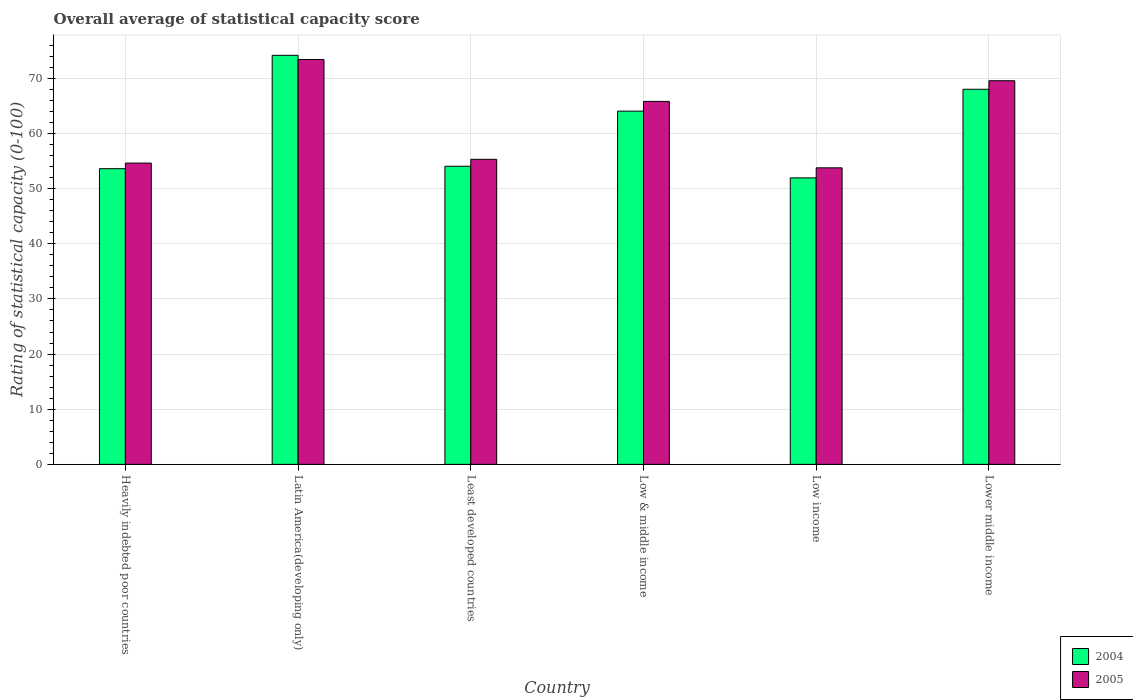What is the label of the 5th group of bars from the left?
Provide a succinct answer. Low income. What is the rating of statistical capacity in 2004 in Low income?
Your answer should be compact. 51.94. Across all countries, what is the maximum rating of statistical capacity in 2005?
Your response must be concise. 73.4. Across all countries, what is the minimum rating of statistical capacity in 2004?
Your answer should be very brief. 51.94. In which country was the rating of statistical capacity in 2004 maximum?
Offer a very short reply. Latin America(developing only). What is the total rating of statistical capacity in 2004 in the graph?
Your answer should be compact. 365.84. What is the difference between the rating of statistical capacity in 2005 in Heavily indebted poor countries and that in Least developed countries?
Ensure brevity in your answer.  -0.69. What is the difference between the rating of statistical capacity in 2005 in Least developed countries and the rating of statistical capacity in 2004 in Lower middle income?
Your answer should be compact. -12.7. What is the average rating of statistical capacity in 2004 per country?
Make the answer very short. 60.97. What is the difference between the rating of statistical capacity of/in 2005 and rating of statistical capacity of/in 2004 in Latin America(developing only)?
Keep it short and to the point. -0.76. What is the ratio of the rating of statistical capacity in 2005 in Latin America(developing only) to that in Low income?
Make the answer very short. 1.37. What is the difference between the highest and the second highest rating of statistical capacity in 2005?
Provide a succinct answer. -7.59. What is the difference between the highest and the lowest rating of statistical capacity in 2004?
Offer a very short reply. 22.22. What does the 2nd bar from the left in Heavily indebted poor countries represents?
Give a very brief answer. 2005. What does the 2nd bar from the right in Heavily indebted poor countries represents?
Offer a very short reply. 2004. How many bars are there?
Make the answer very short. 12. How many countries are there in the graph?
Provide a short and direct response. 6. Does the graph contain grids?
Your response must be concise. Yes. What is the title of the graph?
Make the answer very short. Overall average of statistical capacity score. What is the label or title of the X-axis?
Your response must be concise. Country. What is the label or title of the Y-axis?
Give a very brief answer. Rating of statistical capacity (0-100). What is the Rating of statistical capacity (0-100) of 2004 in Heavily indebted poor countries?
Your response must be concise. 53.61. What is the Rating of statistical capacity (0-100) of 2005 in Heavily indebted poor countries?
Your answer should be very brief. 54.63. What is the Rating of statistical capacity (0-100) in 2004 in Latin America(developing only)?
Provide a succinct answer. 74.17. What is the Rating of statistical capacity (0-100) of 2005 in Latin America(developing only)?
Ensure brevity in your answer.  73.4. What is the Rating of statistical capacity (0-100) in 2004 in Least developed countries?
Give a very brief answer. 54.05. What is the Rating of statistical capacity (0-100) of 2005 in Least developed countries?
Your answer should be compact. 55.32. What is the Rating of statistical capacity (0-100) in 2004 in Low & middle income?
Provide a short and direct response. 64.05. What is the Rating of statistical capacity (0-100) of 2005 in Low & middle income?
Provide a short and direct response. 65.81. What is the Rating of statistical capacity (0-100) in 2004 in Low income?
Ensure brevity in your answer.  51.94. What is the Rating of statistical capacity (0-100) in 2005 in Low income?
Keep it short and to the point. 53.77. What is the Rating of statistical capacity (0-100) in 2004 in Lower middle income?
Provide a short and direct response. 68.01. What is the Rating of statistical capacity (0-100) of 2005 in Lower middle income?
Ensure brevity in your answer.  69.56. Across all countries, what is the maximum Rating of statistical capacity (0-100) in 2004?
Keep it short and to the point. 74.17. Across all countries, what is the maximum Rating of statistical capacity (0-100) in 2005?
Your response must be concise. 73.4. Across all countries, what is the minimum Rating of statistical capacity (0-100) of 2004?
Offer a very short reply. 51.94. Across all countries, what is the minimum Rating of statistical capacity (0-100) of 2005?
Your answer should be very brief. 53.77. What is the total Rating of statistical capacity (0-100) in 2004 in the graph?
Your answer should be compact. 365.84. What is the total Rating of statistical capacity (0-100) of 2005 in the graph?
Give a very brief answer. 372.49. What is the difference between the Rating of statistical capacity (0-100) in 2004 in Heavily indebted poor countries and that in Latin America(developing only)?
Provide a succinct answer. -20.56. What is the difference between the Rating of statistical capacity (0-100) of 2005 in Heavily indebted poor countries and that in Latin America(developing only)?
Your answer should be compact. -18.77. What is the difference between the Rating of statistical capacity (0-100) of 2004 in Heavily indebted poor countries and that in Least developed countries?
Give a very brief answer. -0.44. What is the difference between the Rating of statistical capacity (0-100) in 2005 in Heavily indebted poor countries and that in Least developed countries?
Provide a short and direct response. -0.69. What is the difference between the Rating of statistical capacity (0-100) of 2004 in Heavily indebted poor countries and that in Low & middle income?
Offer a terse response. -10.44. What is the difference between the Rating of statistical capacity (0-100) in 2005 in Heavily indebted poor countries and that in Low & middle income?
Your response must be concise. -11.18. What is the difference between the Rating of statistical capacity (0-100) in 2004 in Heavily indebted poor countries and that in Low income?
Ensure brevity in your answer.  1.67. What is the difference between the Rating of statistical capacity (0-100) in 2005 in Heavily indebted poor countries and that in Low income?
Offer a terse response. 0.86. What is the difference between the Rating of statistical capacity (0-100) in 2004 in Heavily indebted poor countries and that in Lower middle income?
Your answer should be compact. -14.4. What is the difference between the Rating of statistical capacity (0-100) in 2005 in Heavily indebted poor countries and that in Lower middle income?
Your response must be concise. -14.93. What is the difference between the Rating of statistical capacity (0-100) of 2004 in Latin America(developing only) and that in Least developed countries?
Give a very brief answer. 20.11. What is the difference between the Rating of statistical capacity (0-100) in 2005 in Latin America(developing only) and that in Least developed countries?
Your answer should be compact. 18.09. What is the difference between the Rating of statistical capacity (0-100) in 2004 in Latin America(developing only) and that in Low & middle income?
Make the answer very short. 10.12. What is the difference between the Rating of statistical capacity (0-100) of 2005 in Latin America(developing only) and that in Low & middle income?
Ensure brevity in your answer.  7.59. What is the difference between the Rating of statistical capacity (0-100) of 2004 in Latin America(developing only) and that in Low income?
Your answer should be very brief. 22.22. What is the difference between the Rating of statistical capacity (0-100) in 2005 in Latin America(developing only) and that in Low income?
Your response must be concise. 19.63. What is the difference between the Rating of statistical capacity (0-100) of 2004 in Latin America(developing only) and that in Lower middle income?
Ensure brevity in your answer.  6.16. What is the difference between the Rating of statistical capacity (0-100) in 2005 in Latin America(developing only) and that in Lower middle income?
Offer a very short reply. 3.84. What is the difference between the Rating of statistical capacity (0-100) in 2004 in Least developed countries and that in Low & middle income?
Your answer should be very brief. -10. What is the difference between the Rating of statistical capacity (0-100) of 2005 in Least developed countries and that in Low & middle income?
Make the answer very short. -10.5. What is the difference between the Rating of statistical capacity (0-100) of 2004 in Least developed countries and that in Low income?
Your response must be concise. 2.11. What is the difference between the Rating of statistical capacity (0-100) in 2005 in Least developed countries and that in Low income?
Give a very brief answer. 1.55. What is the difference between the Rating of statistical capacity (0-100) of 2004 in Least developed countries and that in Lower middle income?
Provide a succinct answer. -13.96. What is the difference between the Rating of statistical capacity (0-100) of 2005 in Least developed countries and that in Lower middle income?
Keep it short and to the point. -14.25. What is the difference between the Rating of statistical capacity (0-100) in 2004 in Low & middle income and that in Low income?
Provide a short and direct response. 12.1. What is the difference between the Rating of statistical capacity (0-100) of 2005 in Low & middle income and that in Low income?
Your response must be concise. 12.04. What is the difference between the Rating of statistical capacity (0-100) in 2004 in Low & middle income and that in Lower middle income?
Your answer should be very brief. -3.96. What is the difference between the Rating of statistical capacity (0-100) of 2005 in Low & middle income and that in Lower middle income?
Your answer should be compact. -3.75. What is the difference between the Rating of statistical capacity (0-100) of 2004 in Low income and that in Lower middle income?
Ensure brevity in your answer.  -16.07. What is the difference between the Rating of statistical capacity (0-100) of 2005 in Low income and that in Lower middle income?
Your response must be concise. -15.79. What is the difference between the Rating of statistical capacity (0-100) in 2004 in Heavily indebted poor countries and the Rating of statistical capacity (0-100) in 2005 in Latin America(developing only)?
Make the answer very short. -19.79. What is the difference between the Rating of statistical capacity (0-100) of 2004 in Heavily indebted poor countries and the Rating of statistical capacity (0-100) of 2005 in Least developed countries?
Make the answer very short. -1.7. What is the difference between the Rating of statistical capacity (0-100) in 2004 in Heavily indebted poor countries and the Rating of statistical capacity (0-100) in 2005 in Low & middle income?
Provide a short and direct response. -12.2. What is the difference between the Rating of statistical capacity (0-100) of 2004 in Heavily indebted poor countries and the Rating of statistical capacity (0-100) of 2005 in Low income?
Make the answer very short. -0.16. What is the difference between the Rating of statistical capacity (0-100) of 2004 in Heavily indebted poor countries and the Rating of statistical capacity (0-100) of 2005 in Lower middle income?
Provide a short and direct response. -15.95. What is the difference between the Rating of statistical capacity (0-100) of 2004 in Latin America(developing only) and the Rating of statistical capacity (0-100) of 2005 in Least developed countries?
Your answer should be compact. 18.85. What is the difference between the Rating of statistical capacity (0-100) in 2004 in Latin America(developing only) and the Rating of statistical capacity (0-100) in 2005 in Low & middle income?
Ensure brevity in your answer.  8.35. What is the difference between the Rating of statistical capacity (0-100) in 2004 in Latin America(developing only) and the Rating of statistical capacity (0-100) in 2005 in Low income?
Keep it short and to the point. 20.4. What is the difference between the Rating of statistical capacity (0-100) of 2004 in Latin America(developing only) and the Rating of statistical capacity (0-100) of 2005 in Lower middle income?
Offer a terse response. 4.61. What is the difference between the Rating of statistical capacity (0-100) of 2004 in Least developed countries and the Rating of statistical capacity (0-100) of 2005 in Low & middle income?
Give a very brief answer. -11.76. What is the difference between the Rating of statistical capacity (0-100) of 2004 in Least developed countries and the Rating of statistical capacity (0-100) of 2005 in Low income?
Offer a very short reply. 0.28. What is the difference between the Rating of statistical capacity (0-100) in 2004 in Least developed countries and the Rating of statistical capacity (0-100) in 2005 in Lower middle income?
Ensure brevity in your answer.  -15.51. What is the difference between the Rating of statistical capacity (0-100) of 2004 in Low & middle income and the Rating of statistical capacity (0-100) of 2005 in Low income?
Provide a succinct answer. 10.28. What is the difference between the Rating of statistical capacity (0-100) in 2004 in Low & middle income and the Rating of statistical capacity (0-100) in 2005 in Lower middle income?
Give a very brief answer. -5.51. What is the difference between the Rating of statistical capacity (0-100) in 2004 in Low income and the Rating of statistical capacity (0-100) in 2005 in Lower middle income?
Give a very brief answer. -17.62. What is the average Rating of statistical capacity (0-100) of 2004 per country?
Provide a short and direct response. 60.97. What is the average Rating of statistical capacity (0-100) in 2005 per country?
Keep it short and to the point. 62.08. What is the difference between the Rating of statistical capacity (0-100) of 2004 and Rating of statistical capacity (0-100) of 2005 in Heavily indebted poor countries?
Make the answer very short. -1.02. What is the difference between the Rating of statistical capacity (0-100) in 2004 and Rating of statistical capacity (0-100) in 2005 in Latin America(developing only)?
Your response must be concise. 0.76. What is the difference between the Rating of statistical capacity (0-100) of 2004 and Rating of statistical capacity (0-100) of 2005 in Least developed countries?
Ensure brevity in your answer.  -1.26. What is the difference between the Rating of statistical capacity (0-100) in 2004 and Rating of statistical capacity (0-100) in 2005 in Low & middle income?
Your answer should be very brief. -1.76. What is the difference between the Rating of statistical capacity (0-100) in 2004 and Rating of statistical capacity (0-100) in 2005 in Low income?
Your response must be concise. -1.83. What is the difference between the Rating of statistical capacity (0-100) of 2004 and Rating of statistical capacity (0-100) of 2005 in Lower middle income?
Provide a succinct answer. -1.55. What is the ratio of the Rating of statistical capacity (0-100) of 2004 in Heavily indebted poor countries to that in Latin America(developing only)?
Provide a succinct answer. 0.72. What is the ratio of the Rating of statistical capacity (0-100) of 2005 in Heavily indebted poor countries to that in Latin America(developing only)?
Provide a succinct answer. 0.74. What is the ratio of the Rating of statistical capacity (0-100) of 2005 in Heavily indebted poor countries to that in Least developed countries?
Offer a very short reply. 0.99. What is the ratio of the Rating of statistical capacity (0-100) in 2004 in Heavily indebted poor countries to that in Low & middle income?
Provide a succinct answer. 0.84. What is the ratio of the Rating of statistical capacity (0-100) in 2005 in Heavily indebted poor countries to that in Low & middle income?
Your answer should be compact. 0.83. What is the ratio of the Rating of statistical capacity (0-100) in 2004 in Heavily indebted poor countries to that in Low income?
Your answer should be compact. 1.03. What is the ratio of the Rating of statistical capacity (0-100) of 2005 in Heavily indebted poor countries to that in Low income?
Provide a short and direct response. 1.02. What is the ratio of the Rating of statistical capacity (0-100) in 2004 in Heavily indebted poor countries to that in Lower middle income?
Offer a very short reply. 0.79. What is the ratio of the Rating of statistical capacity (0-100) in 2005 in Heavily indebted poor countries to that in Lower middle income?
Give a very brief answer. 0.79. What is the ratio of the Rating of statistical capacity (0-100) of 2004 in Latin America(developing only) to that in Least developed countries?
Provide a succinct answer. 1.37. What is the ratio of the Rating of statistical capacity (0-100) in 2005 in Latin America(developing only) to that in Least developed countries?
Ensure brevity in your answer.  1.33. What is the ratio of the Rating of statistical capacity (0-100) in 2004 in Latin America(developing only) to that in Low & middle income?
Your answer should be very brief. 1.16. What is the ratio of the Rating of statistical capacity (0-100) of 2005 in Latin America(developing only) to that in Low & middle income?
Offer a terse response. 1.12. What is the ratio of the Rating of statistical capacity (0-100) of 2004 in Latin America(developing only) to that in Low income?
Provide a short and direct response. 1.43. What is the ratio of the Rating of statistical capacity (0-100) of 2005 in Latin America(developing only) to that in Low income?
Keep it short and to the point. 1.37. What is the ratio of the Rating of statistical capacity (0-100) of 2004 in Latin America(developing only) to that in Lower middle income?
Give a very brief answer. 1.09. What is the ratio of the Rating of statistical capacity (0-100) in 2005 in Latin America(developing only) to that in Lower middle income?
Offer a terse response. 1.06. What is the ratio of the Rating of statistical capacity (0-100) in 2004 in Least developed countries to that in Low & middle income?
Make the answer very short. 0.84. What is the ratio of the Rating of statistical capacity (0-100) of 2005 in Least developed countries to that in Low & middle income?
Offer a very short reply. 0.84. What is the ratio of the Rating of statistical capacity (0-100) in 2004 in Least developed countries to that in Low income?
Give a very brief answer. 1.04. What is the ratio of the Rating of statistical capacity (0-100) of 2005 in Least developed countries to that in Low income?
Your response must be concise. 1.03. What is the ratio of the Rating of statistical capacity (0-100) in 2004 in Least developed countries to that in Lower middle income?
Your response must be concise. 0.79. What is the ratio of the Rating of statistical capacity (0-100) of 2005 in Least developed countries to that in Lower middle income?
Offer a terse response. 0.8. What is the ratio of the Rating of statistical capacity (0-100) of 2004 in Low & middle income to that in Low income?
Offer a very short reply. 1.23. What is the ratio of the Rating of statistical capacity (0-100) of 2005 in Low & middle income to that in Low income?
Offer a terse response. 1.22. What is the ratio of the Rating of statistical capacity (0-100) of 2004 in Low & middle income to that in Lower middle income?
Offer a very short reply. 0.94. What is the ratio of the Rating of statistical capacity (0-100) in 2005 in Low & middle income to that in Lower middle income?
Keep it short and to the point. 0.95. What is the ratio of the Rating of statistical capacity (0-100) in 2004 in Low income to that in Lower middle income?
Your response must be concise. 0.76. What is the ratio of the Rating of statistical capacity (0-100) in 2005 in Low income to that in Lower middle income?
Your answer should be compact. 0.77. What is the difference between the highest and the second highest Rating of statistical capacity (0-100) in 2004?
Offer a terse response. 6.16. What is the difference between the highest and the second highest Rating of statistical capacity (0-100) of 2005?
Offer a very short reply. 3.84. What is the difference between the highest and the lowest Rating of statistical capacity (0-100) in 2004?
Offer a terse response. 22.22. What is the difference between the highest and the lowest Rating of statistical capacity (0-100) of 2005?
Offer a very short reply. 19.63. 